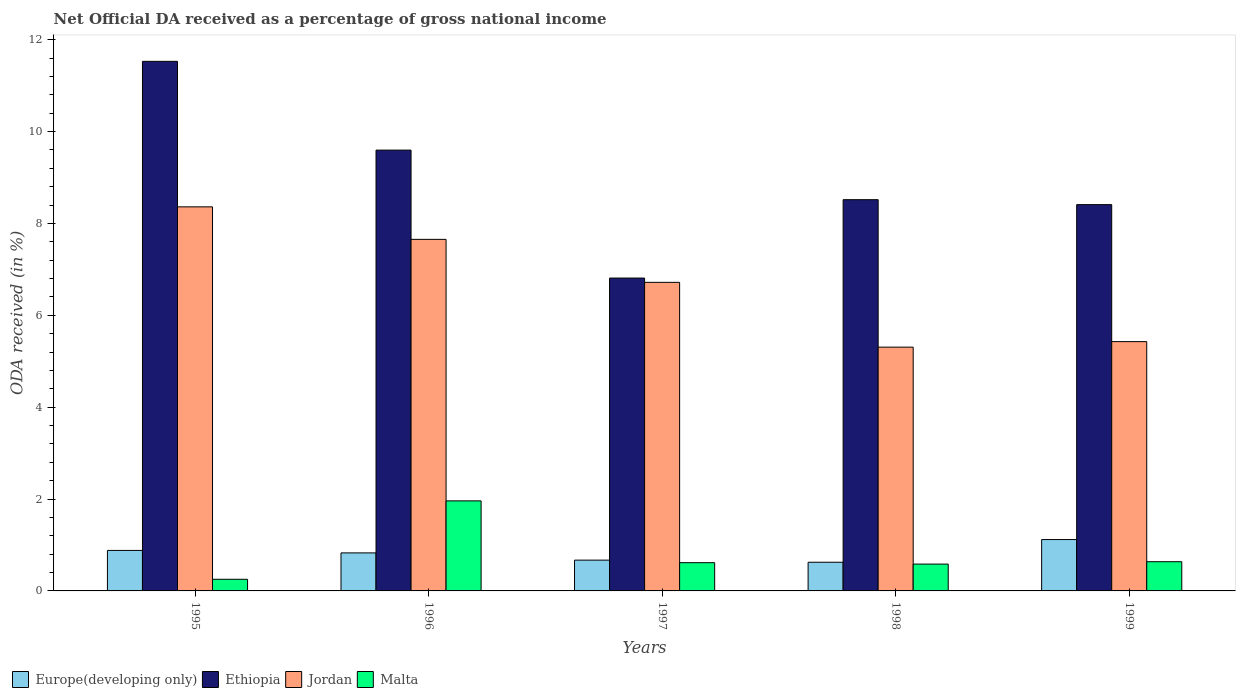How many groups of bars are there?
Give a very brief answer. 5. How many bars are there on the 2nd tick from the left?
Your answer should be very brief. 4. What is the label of the 4th group of bars from the left?
Offer a very short reply. 1998. In how many cases, is the number of bars for a given year not equal to the number of legend labels?
Your answer should be compact. 0. What is the net official DA received in Jordan in 1995?
Provide a short and direct response. 8.36. Across all years, what is the maximum net official DA received in Jordan?
Your response must be concise. 8.36. Across all years, what is the minimum net official DA received in Europe(developing only)?
Make the answer very short. 0.62. What is the total net official DA received in Jordan in the graph?
Your answer should be very brief. 33.46. What is the difference between the net official DA received in Jordan in 1997 and that in 1998?
Ensure brevity in your answer.  1.41. What is the difference between the net official DA received in Malta in 1997 and the net official DA received in Europe(developing only) in 1999?
Your answer should be compact. -0.5. What is the average net official DA received in Europe(developing only) per year?
Offer a very short reply. 0.82. In the year 1998, what is the difference between the net official DA received in Ethiopia and net official DA received in Europe(developing only)?
Keep it short and to the point. 7.89. In how many years, is the net official DA received in Jordan greater than 0.4 %?
Keep it short and to the point. 5. What is the ratio of the net official DA received in Malta in 1997 to that in 1998?
Ensure brevity in your answer.  1.05. Is the net official DA received in Europe(developing only) in 1996 less than that in 1999?
Keep it short and to the point. Yes. What is the difference between the highest and the second highest net official DA received in Malta?
Offer a very short reply. 1.32. What is the difference between the highest and the lowest net official DA received in Ethiopia?
Your response must be concise. 4.72. In how many years, is the net official DA received in Malta greater than the average net official DA received in Malta taken over all years?
Provide a succinct answer. 1. Is it the case that in every year, the sum of the net official DA received in Jordan and net official DA received in Ethiopia is greater than the sum of net official DA received in Malta and net official DA received in Europe(developing only)?
Keep it short and to the point. Yes. What does the 3rd bar from the left in 1997 represents?
Ensure brevity in your answer.  Jordan. What does the 2nd bar from the right in 1999 represents?
Your response must be concise. Jordan. Is it the case that in every year, the sum of the net official DA received in Ethiopia and net official DA received in Europe(developing only) is greater than the net official DA received in Malta?
Your answer should be very brief. Yes. How many bars are there?
Offer a terse response. 20. What is the difference between two consecutive major ticks on the Y-axis?
Give a very brief answer. 2. Does the graph contain any zero values?
Provide a short and direct response. No. How many legend labels are there?
Your answer should be very brief. 4. What is the title of the graph?
Give a very brief answer. Net Official DA received as a percentage of gross national income. What is the label or title of the X-axis?
Give a very brief answer. Years. What is the label or title of the Y-axis?
Make the answer very short. ODA received (in %). What is the ODA received (in %) in Europe(developing only) in 1995?
Ensure brevity in your answer.  0.88. What is the ODA received (in %) of Ethiopia in 1995?
Provide a succinct answer. 11.53. What is the ODA received (in %) of Jordan in 1995?
Provide a short and direct response. 8.36. What is the ODA received (in %) in Malta in 1995?
Provide a succinct answer. 0.25. What is the ODA received (in %) of Europe(developing only) in 1996?
Provide a succinct answer. 0.83. What is the ODA received (in %) in Ethiopia in 1996?
Your answer should be very brief. 9.6. What is the ODA received (in %) in Jordan in 1996?
Give a very brief answer. 7.65. What is the ODA received (in %) of Malta in 1996?
Give a very brief answer. 1.96. What is the ODA received (in %) of Europe(developing only) in 1997?
Make the answer very short. 0.67. What is the ODA received (in %) in Ethiopia in 1997?
Your response must be concise. 6.81. What is the ODA received (in %) in Jordan in 1997?
Give a very brief answer. 6.72. What is the ODA received (in %) of Malta in 1997?
Provide a short and direct response. 0.61. What is the ODA received (in %) in Europe(developing only) in 1998?
Keep it short and to the point. 0.62. What is the ODA received (in %) in Ethiopia in 1998?
Your response must be concise. 8.52. What is the ODA received (in %) in Jordan in 1998?
Give a very brief answer. 5.31. What is the ODA received (in %) in Malta in 1998?
Your response must be concise. 0.58. What is the ODA received (in %) in Europe(developing only) in 1999?
Your response must be concise. 1.12. What is the ODA received (in %) of Ethiopia in 1999?
Your answer should be very brief. 8.41. What is the ODA received (in %) of Jordan in 1999?
Make the answer very short. 5.43. What is the ODA received (in %) in Malta in 1999?
Your response must be concise. 0.64. Across all years, what is the maximum ODA received (in %) in Europe(developing only)?
Your answer should be very brief. 1.12. Across all years, what is the maximum ODA received (in %) in Ethiopia?
Make the answer very short. 11.53. Across all years, what is the maximum ODA received (in %) in Jordan?
Your answer should be very brief. 8.36. Across all years, what is the maximum ODA received (in %) of Malta?
Your response must be concise. 1.96. Across all years, what is the minimum ODA received (in %) of Europe(developing only)?
Your answer should be very brief. 0.62. Across all years, what is the minimum ODA received (in %) in Ethiopia?
Your response must be concise. 6.81. Across all years, what is the minimum ODA received (in %) in Jordan?
Keep it short and to the point. 5.31. Across all years, what is the minimum ODA received (in %) in Malta?
Your answer should be very brief. 0.25. What is the total ODA received (in %) in Europe(developing only) in the graph?
Your answer should be very brief. 4.12. What is the total ODA received (in %) of Ethiopia in the graph?
Provide a short and direct response. 44.86. What is the total ODA received (in %) in Jordan in the graph?
Keep it short and to the point. 33.46. What is the total ODA received (in %) in Malta in the graph?
Provide a short and direct response. 4.05. What is the difference between the ODA received (in %) of Europe(developing only) in 1995 and that in 1996?
Your response must be concise. 0.05. What is the difference between the ODA received (in %) of Ethiopia in 1995 and that in 1996?
Provide a short and direct response. 1.93. What is the difference between the ODA received (in %) in Jordan in 1995 and that in 1996?
Your answer should be very brief. 0.71. What is the difference between the ODA received (in %) of Malta in 1995 and that in 1996?
Ensure brevity in your answer.  -1.71. What is the difference between the ODA received (in %) in Europe(developing only) in 1995 and that in 1997?
Your response must be concise. 0.21. What is the difference between the ODA received (in %) of Ethiopia in 1995 and that in 1997?
Make the answer very short. 4.72. What is the difference between the ODA received (in %) of Jordan in 1995 and that in 1997?
Your answer should be very brief. 1.64. What is the difference between the ODA received (in %) in Malta in 1995 and that in 1997?
Give a very brief answer. -0.36. What is the difference between the ODA received (in %) of Europe(developing only) in 1995 and that in 1998?
Keep it short and to the point. 0.26. What is the difference between the ODA received (in %) in Ethiopia in 1995 and that in 1998?
Offer a terse response. 3.01. What is the difference between the ODA received (in %) of Jordan in 1995 and that in 1998?
Your answer should be compact. 3.05. What is the difference between the ODA received (in %) of Malta in 1995 and that in 1998?
Give a very brief answer. -0.33. What is the difference between the ODA received (in %) of Europe(developing only) in 1995 and that in 1999?
Your response must be concise. -0.24. What is the difference between the ODA received (in %) of Ethiopia in 1995 and that in 1999?
Offer a very short reply. 3.12. What is the difference between the ODA received (in %) in Jordan in 1995 and that in 1999?
Ensure brevity in your answer.  2.93. What is the difference between the ODA received (in %) in Malta in 1995 and that in 1999?
Provide a short and direct response. -0.38. What is the difference between the ODA received (in %) of Europe(developing only) in 1996 and that in 1997?
Ensure brevity in your answer.  0.16. What is the difference between the ODA received (in %) in Ethiopia in 1996 and that in 1997?
Provide a short and direct response. 2.78. What is the difference between the ODA received (in %) of Jordan in 1996 and that in 1997?
Give a very brief answer. 0.94. What is the difference between the ODA received (in %) of Malta in 1996 and that in 1997?
Offer a terse response. 1.35. What is the difference between the ODA received (in %) in Europe(developing only) in 1996 and that in 1998?
Make the answer very short. 0.2. What is the difference between the ODA received (in %) in Ethiopia in 1996 and that in 1998?
Keep it short and to the point. 1.08. What is the difference between the ODA received (in %) of Jordan in 1996 and that in 1998?
Give a very brief answer. 2.35. What is the difference between the ODA received (in %) of Malta in 1996 and that in 1998?
Provide a succinct answer. 1.38. What is the difference between the ODA received (in %) in Europe(developing only) in 1996 and that in 1999?
Your answer should be very brief. -0.29. What is the difference between the ODA received (in %) of Ethiopia in 1996 and that in 1999?
Keep it short and to the point. 1.19. What is the difference between the ODA received (in %) of Jordan in 1996 and that in 1999?
Offer a terse response. 2.23. What is the difference between the ODA received (in %) of Malta in 1996 and that in 1999?
Provide a short and direct response. 1.32. What is the difference between the ODA received (in %) in Europe(developing only) in 1997 and that in 1998?
Give a very brief answer. 0.05. What is the difference between the ODA received (in %) in Ethiopia in 1997 and that in 1998?
Give a very brief answer. -1.71. What is the difference between the ODA received (in %) in Jordan in 1997 and that in 1998?
Your answer should be very brief. 1.41. What is the difference between the ODA received (in %) of Malta in 1997 and that in 1998?
Provide a short and direct response. 0.03. What is the difference between the ODA received (in %) in Europe(developing only) in 1997 and that in 1999?
Offer a terse response. -0.45. What is the difference between the ODA received (in %) of Ethiopia in 1997 and that in 1999?
Offer a terse response. -1.6. What is the difference between the ODA received (in %) in Jordan in 1997 and that in 1999?
Your answer should be compact. 1.29. What is the difference between the ODA received (in %) in Malta in 1997 and that in 1999?
Give a very brief answer. -0.02. What is the difference between the ODA received (in %) in Europe(developing only) in 1998 and that in 1999?
Keep it short and to the point. -0.49. What is the difference between the ODA received (in %) in Ethiopia in 1998 and that in 1999?
Provide a short and direct response. 0.11. What is the difference between the ODA received (in %) of Jordan in 1998 and that in 1999?
Give a very brief answer. -0.12. What is the difference between the ODA received (in %) in Malta in 1998 and that in 1999?
Your response must be concise. -0.05. What is the difference between the ODA received (in %) of Europe(developing only) in 1995 and the ODA received (in %) of Ethiopia in 1996?
Provide a short and direct response. -8.71. What is the difference between the ODA received (in %) in Europe(developing only) in 1995 and the ODA received (in %) in Jordan in 1996?
Your answer should be compact. -6.77. What is the difference between the ODA received (in %) in Europe(developing only) in 1995 and the ODA received (in %) in Malta in 1996?
Your answer should be compact. -1.08. What is the difference between the ODA received (in %) in Ethiopia in 1995 and the ODA received (in %) in Jordan in 1996?
Ensure brevity in your answer.  3.87. What is the difference between the ODA received (in %) in Ethiopia in 1995 and the ODA received (in %) in Malta in 1996?
Ensure brevity in your answer.  9.57. What is the difference between the ODA received (in %) in Jordan in 1995 and the ODA received (in %) in Malta in 1996?
Your response must be concise. 6.4. What is the difference between the ODA received (in %) in Europe(developing only) in 1995 and the ODA received (in %) in Ethiopia in 1997?
Provide a succinct answer. -5.93. What is the difference between the ODA received (in %) of Europe(developing only) in 1995 and the ODA received (in %) of Jordan in 1997?
Your response must be concise. -5.84. What is the difference between the ODA received (in %) in Europe(developing only) in 1995 and the ODA received (in %) in Malta in 1997?
Provide a succinct answer. 0.27. What is the difference between the ODA received (in %) of Ethiopia in 1995 and the ODA received (in %) of Jordan in 1997?
Keep it short and to the point. 4.81. What is the difference between the ODA received (in %) of Ethiopia in 1995 and the ODA received (in %) of Malta in 1997?
Provide a short and direct response. 10.91. What is the difference between the ODA received (in %) of Jordan in 1995 and the ODA received (in %) of Malta in 1997?
Provide a short and direct response. 7.75. What is the difference between the ODA received (in %) of Europe(developing only) in 1995 and the ODA received (in %) of Ethiopia in 1998?
Offer a terse response. -7.63. What is the difference between the ODA received (in %) in Europe(developing only) in 1995 and the ODA received (in %) in Jordan in 1998?
Provide a short and direct response. -4.43. What is the difference between the ODA received (in %) in Europe(developing only) in 1995 and the ODA received (in %) in Malta in 1998?
Give a very brief answer. 0.3. What is the difference between the ODA received (in %) in Ethiopia in 1995 and the ODA received (in %) in Jordan in 1998?
Ensure brevity in your answer.  6.22. What is the difference between the ODA received (in %) in Ethiopia in 1995 and the ODA received (in %) in Malta in 1998?
Give a very brief answer. 10.94. What is the difference between the ODA received (in %) in Jordan in 1995 and the ODA received (in %) in Malta in 1998?
Your answer should be compact. 7.78. What is the difference between the ODA received (in %) of Europe(developing only) in 1995 and the ODA received (in %) of Ethiopia in 1999?
Ensure brevity in your answer.  -7.53. What is the difference between the ODA received (in %) in Europe(developing only) in 1995 and the ODA received (in %) in Jordan in 1999?
Your response must be concise. -4.55. What is the difference between the ODA received (in %) of Europe(developing only) in 1995 and the ODA received (in %) of Malta in 1999?
Make the answer very short. 0.25. What is the difference between the ODA received (in %) in Ethiopia in 1995 and the ODA received (in %) in Jordan in 1999?
Offer a very short reply. 6.1. What is the difference between the ODA received (in %) of Ethiopia in 1995 and the ODA received (in %) of Malta in 1999?
Your answer should be very brief. 10.89. What is the difference between the ODA received (in %) of Jordan in 1995 and the ODA received (in %) of Malta in 1999?
Provide a succinct answer. 7.72. What is the difference between the ODA received (in %) of Europe(developing only) in 1996 and the ODA received (in %) of Ethiopia in 1997?
Make the answer very short. -5.98. What is the difference between the ODA received (in %) of Europe(developing only) in 1996 and the ODA received (in %) of Jordan in 1997?
Keep it short and to the point. -5.89. What is the difference between the ODA received (in %) in Europe(developing only) in 1996 and the ODA received (in %) in Malta in 1997?
Your answer should be very brief. 0.21. What is the difference between the ODA received (in %) in Ethiopia in 1996 and the ODA received (in %) in Jordan in 1997?
Ensure brevity in your answer.  2.88. What is the difference between the ODA received (in %) of Ethiopia in 1996 and the ODA received (in %) of Malta in 1997?
Keep it short and to the point. 8.98. What is the difference between the ODA received (in %) in Jordan in 1996 and the ODA received (in %) in Malta in 1997?
Provide a succinct answer. 7.04. What is the difference between the ODA received (in %) of Europe(developing only) in 1996 and the ODA received (in %) of Ethiopia in 1998?
Your answer should be compact. -7.69. What is the difference between the ODA received (in %) in Europe(developing only) in 1996 and the ODA received (in %) in Jordan in 1998?
Offer a terse response. -4.48. What is the difference between the ODA received (in %) of Europe(developing only) in 1996 and the ODA received (in %) of Malta in 1998?
Your response must be concise. 0.24. What is the difference between the ODA received (in %) in Ethiopia in 1996 and the ODA received (in %) in Jordan in 1998?
Your answer should be very brief. 4.29. What is the difference between the ODA received (in %) of Ethiopia in 1996 and the ODA received (in %) of Malta in 1998?
Your answer should be very brief. 9.01. What is the difference between the ODA received (in %) of Jordan in 1996 and the ODA received (in %) of Malta in 1998?
Keep it short and to the point. 7.07. What is the difference between the ODA received (in %) of Europe(developing only) in 1996 and the ODA received (in %) of Ethiopia in 1999?
Your response must be concise. -7.58. What is the difference between the ODA received (in %) of Europe(developing only) in 1996 and the ODA received (in %) of Jordan in 1999?
Offer a very short reply. -4.6. What is the difference between the ODA received (in %) of Europe(developing only) in 1996 and the ODA received (in %) of Malta in 1999?
Provide a short and direct response. 0.19. What is the difference between the ODA received (in %) of Ethiopia in 1996 and the ODA received (in %) of Jordan in 1999?
Offer a very short reply. 4.17. What is the difference between the ODA received (in %) of Ethiopia in 1996 and the ODA received (in %) of Malta in 1999?
Give a very brief answer. 8.96. What is the difference between the ODA received (in %) in Jordan in 1996 and the ODA received (in %) in Malta in 1999?
Your answer should be very brief. 7.02. What is the difference between the ODA received (in %) in Europe(developing only) in 1997 and the ODA received (in %) in Ethiopia in 1998?
Give a very brief answer. -7.85. What is the difference between the ODA received (in %) in Europe(developing only) in 1997 and the ODA received (in %) in Jordan in 1998?
Make the answer very short. -4.64. What is the difference between the ODA received (in %) in Europe(developing only) in 1997 and the ODA received (in %) in Malta in 1998?
Provide a succinct answer. 0.09. What is the difference between the ODA received (in %) of Ethiopia in 1997 and the ODA received (in %) of Jordan in 1998?
Your answer should be compact. 1.5. What is the difference between the ODA received (in %) of Ethiopia in 1997 and the ODA received (in %) of Malta in 1998?
Your answer should be very brief. 6.23. What is the difference between the ODA received (in %) in Jordan in 1997 and the ODA received (in %) in Malta in 1998?
Offer a very short reply. 6.13. What is the difference between the ODA received (in %) in Europe(developing only) in 1997 and the ODA received (in %) in Ethiopia in 1999?
Keep it short and to the point. -7.74. What is the difference between the ODA received (in %) in Europe(developing only) in 1997 and the ODA received (in %) in Jordan in 1999?
Keep it short and to the point. -4.76. What is the difference between the ODA received (in %) of Europe(developing only) in 1997 and the ODA received (in %) of Malta in 1999?
Your answer should be very brief. 0.03. What is the difference between the ODA received (in %) of Ethiopia in 1997 and the ODA received (in %) of Jordan in 1999?
Your answer should be very brief. 1.38. What is the difference between the ODA received (in %) of Ethiopia in 1997 and the ODA received (in %) of Malta in 1999?
Offer a very short reply. 6.17. What is the difference between the ODA received (in %) of Jordan in 1997 and the ODA received (in %) of Malta in 1999?
Give a very brief answer. 6.08. What is the difference between the ODA received (in %) of Europe(developing only) in 1998 and the ODA received (in %) of Ethiopia in 1999?
Offer a very short reply. -7.78. What is the difference between the ODA received (in %) of Europe(developing only) in 1998 and the ODA received (in %) of Jordan in 1999?
Ensure brevity in your answer.  -4.8. What is the difference between the ODA received (in %) in Europe(developing only) in 1998 and the ODA received (in %) in Malta in 1999?
Provide a short and direct response. -0.01. What is the difference between the ODA received (in %) in Ethiopia in 1998 and the ODA received (in %) in Jordan in 1999?
Your answer should be compact. 3.09. What is the difference between the ODA received (in %) in Ethiopia in 1998 and the ODA received (in %) in Malta in 1999?
Offer a terse response. 7.88. What is the difference between the ODA received (in %) in Jordan in 1998 and the ODA received (in %) in Malta in 1999?
Your response must be concise. 4.67. What is the average ODA received (in %) of Europe(developing only) per year?
Your answer should be compact. 0.82. What is the average ODA received (in %) of Ethiopia per year?
Ensure brevity in your answer.  8.97. What is the average ODA received (in %) of Jordan per year?
Keep it short and to the point. 6.69. What is the average ODA received (in %) of Malta per year?
Keep it short and to the point. 0.81. In the year 1995, what is the difference between the ODA received (in %) of Europe(developing only) and ODA received (in %) of Ethiopia?
Your answer should be very brief. -10.65. In the year 1995, what is the difference between the ODA received (in %) of Europe(developing only) and ODA received (in %) of Jordan?
Provide a short and direct response. -7.48. In the year 1995, what is the difference between the ODA received (in %) in Europe(developing only) and ODA received (in %) in Malta?
Make the answer very short. 0.63. In the year 1995, what is the difference between the ODA received (in %) of Ethiopia and ODA received (in %) of Jordan?
Provide a short and direct response. 3.17. In the year 1995, what is the difference between the ODA received (in %) in Ethiopia and ODA received (in %) in Malta?
Your answer should be compact. 11.27. In the year 1995, what is the difference between the ODA received (in %) in Jordan and ODA received (in %) in Malta?
Offer a terse response. 8.11. In the year 1996, what is the difference between the ODA received (in %) of Europe(developing only) and ODA received (in %) of Ethiopia?
Your response must be concise. -8.77. In the year 1996, what is the difference between the ODA received (in %) of Europe(developing only) and ODA received (in %) of Jordan?
Your response must be concise. -6.83. In the year 1996, what is the difference between the ODA received (in %) of Europe(developing only) and ODA received (in %) of Malta?
Provide a succinct answer. -1.13. In the year 1996, what is the difference between the ODA received (in %) in Ethiopia and ODA received (in %) in Jordan?
Your answer should be very brief. 1.94. In the year 1996, what is the difference between the ODA received (in %) in Ethiopia and ODA received (in %) in Malta?
Provide a succinct answer. 7.64. In the year 1996, what is the difference between the ODA received (in %) in Jordan and ODA received (in %) in Malta?
Ensure brevity in your answer.  5.69. In the year 1997, what is the difference between the ODA received (in %) of Europe(developing only) and ODA received (in %) of Ethiopia?
Provide a succinct answer. -6.14. In the year 1997, what is the difference between the ODA received (in %) of Europe(developing only) and ODA received (in %) of Jordan?
Ensure brevity in your answer.  -6.05. In the year 1997, what is the difference between the ODA received (in %) in Europe(developing only) and ODA received (in %) in Malta?
Ensure brevity in your answer.  0.06. In the year 1997, what is the difference between the ODA received (in %) in Ethiopia and ODA received (in %) in Jordan?
Offer a very short reply. 0.09. In the year 1997, what is the difference between the ODA received (in %) in Ethiopia and ODA received (in %) in Malta?
Provide a succinct answer. 6.2. In the year 1997, what is the difference between the ODA received (in %) in Jordan and ODA received (in %) in Malta?
Your answer should be compact. 6.1. In the year 1998, what is the difference between the ODA received (in %) in Europe(developing only) and ODA received (in %) in Ethiopia?
Give a very brief answer. -7.89. In the year 1998, what is the difference between the ODA received (in %) in Europe(developing only) and ODA received (in %) in Jordan?
Provide a succinct answer. -4.68. In the year 1998, what is the difference between the ODA received (in %) in Europe(developing only) and ODA received (in %) in Malta?
Your answer should be compact. 0.04. In the year 1998, what is the difference between the ODA received (in %) of Ethiopia and ODA received (in %) of Jordan?
Offer a very short reply. 3.21. In the year 1998, what is the difference between the ODA received (in %) of Ethiopia and ODA received (in %) of Malta?
Your answer should be compact. 7.93. In the year 1998, what is the difference between the ODA received (in %) in Jordan and ODA received (in %) in Malta?
Your answer should be compact. 4.72. In the year 1999, what is the difference between the ODA received (in %) in Europe(developing only) and ODA received (in %) in Ethiopia?
Your answer should be very brief. -7.29. In the year 1999, what is the difference between the ODA received (in %) of Europe(developing only) and ODA received (in %) of Jordan?
Offer a very short reply. -4.31. In the year 1999, what is the difference between the ODA received (in %) of Europe(developing only) and ODA received (in %) of Malta?
Your answer should be compact. 0.48. In the year 1999, what is the difference between the ODA received (in %) of Ethiopia and ODA received (in %) of Jordan?
Your response must be concise. 2.98. In the year 1999, what is the difference between the ODA received (in %) of Ethiopia and ODA received (in %) of Malta?
Provide a short and direct response. 7.77. In the year 1999, what is the difference between the ODA received (in %) of Jordan and ODA received (in %) of Malta?
Provide a succinct answer. 4.79. What is the ratio of the ODA received (in %) in Europe(developing only) in 1995 to that in 1996?
Ensure brevity in your answer.  1.06. What is the ratio of the ODA received (in %) of Ethiopia in 1995 to that in 1996?
Keep it short and to the point. 1.2. What is the ratio of the ODA received (in %) in Jordan in 1995 to that in 1996?
Provide a succinct answer. 1.09. What is the ratio of the ODA received (in %) in Malta in 1995 to that in 1996?
Make the answer very short. 0.13. What is the ratio of the ODA received (in %) of Europe(developing only) in 1995 to that in 1997?
Provide a succinct answer. 1.31. What is the ratio of the ODA received (in %) in Ethiopia in 1995 to that in 1997?
Ensure brevity in your answer.  1.69. What is the ratio of the ODA received (in %) of Jordan in 1995 to that in 1997?
Provide a succinct answer. 1.24. What is the ratio of the ODA received (in %) of Malta in 1995 to that in 1997?
Give a very brief answer. 0.41. What is the ratio of the ODA received (in %) in Europe(developing only) in 1995 to that in 1998?
Offer a very short reply. 1.41. What is the ratio of the ODA received (in %) of Ethiopia in 1995 to that in 1998?
Offer a terse response. 1.35. What is the ratio of the ODA received (in %) of Jordan in 1995 to that in 1998?
Your response must be concise. 1.58. What is the ratio of the ODA received (in %) in Malta in 1995 to that in 1998?
Provide a succinct answer. 0.43. What is the ratio of the ODA received (in %) in Europe(developing only) in 1995 to that in 1999?
Offer a very short reply. 0.79. What is the ratio of the ODA received (in %) in Ethiopia in 1995 to that in 1999?
Make the answer very short. 1.37. What is the ratio of the ODA received (in %) of Jordan in 1995 to that in 1999?
Offer a very short reply. 1.54. What is the ratio of the ODA received (in %) of Malta in 1995 to that in 1999?
Make the answer very short. 0.4. What is the ratio of the ODA received (in %) of Europe(developing only) in 1996 to that in 1997?
Your answer should be very brief. 1.23. What is the ratio of the ODA received (in %) in Ethiopia in 1996 to that in 1997?
Provide a succinct answer. 1.41. What is the ratio of the ODA received (in %) in Jordan in 1996 to that in 1997?
Ensure brevity in your answer.  1.14. What is the ratio of the ODA received (in %) of Malta in 1996 to that in 1997?
Your answer should be compact. 3.19. What is the ratio of the ODA received (in %) in Europe(developing only) in 1996 to that in 1998?
Offer a terse response. 1.33. What is the ratio of the ODA received (in %) of Ethiopia in 1996 to that in 1998?
Keep it short and to the point. 1.13. What is the ratio of the ODA received (in %) of Jordan in 1996 to that in 1998?
Your response must be concise. 1.44. What is the ratio of the ODA received (in %) of Malta in 1996 to that in 1998?
Your answer should be compact. 3.36. What is the ratio of the ODA received (in %) in Europe(developing only) in 1996 to that in 1999?
Provide a succinct answer. 0.74. What is the ratio of the ODA received (in %) of Ethiopia in 1996 to that in 1999?
Ensure brevity in your answer.  1.14. What is the ratio of the ODA received (in %) of Jordan in 1996 to that in 1999?
Give a very brief answer. 1.41. What is the ratio of the ODA received (in %) in Malta in 1996 to that in 1999?
Offer a terse response. 3.08. What is the ratio of the ODA received (in %) in Europe(developing only) in 1997 to that in 1998?
Offer a terse response. 1.07. What is the ratio of the ODA received (in %) of Ethiopia in 1997 to that in 1998?
Offer a terse response. 0.8. What is the ratio of the ODA received (in %) of Jordan in 1997 to that in 1998?
Give a very brief answer. 1.27. What is the ratio of the ODA received (in %) in Malta in 1997 to that in 1998?
Your response must be concise. 1.05. What is the ratio of the ODA received (in %) of Europe(developing only) in 1997 to that in 1999?
Your response must be concise. 0.6. What is the ratio of the ODA received (in %) in Ethiopia in 1997 to that in 1999?
Offer a very short reply. 0.81. What is the ratio of the ODA received (in %) of Jordan in 1997 to that in 1999?
Your response must be concise. 1.24. What is the ratio of the ODA received (in %) in Malta in 1997 to that in 1999?
Your answer should be compact. 0.97. What is the ratio of the ODA received (in %) of Europe(developing only) in 1998 to that in 1999?
Make the answer very short. 0.56. What is the ratio of the ODA received (in %) of Ethiopia in 1998 to that in 1999?
Keep it short and to the point. 1.01. What is the ratio of the ODA received (in %) in Jordan in 1998 to that in 1999?
Provide a succinct answer. 0.98. What is the ratio of the ODA received (in %) in Malta in 1998 to that in 1999?
Offer a terse response. 0.92. What is the difference between the highest and the second highest ODA received (in %) in Europe(developing only)?
Give a very brief answer. 0.24. What is the difference between the highest and the second highest ODA received (in %) in Ethiopia?
Offer a very short reply. 1.93. What is the difference between the highest and the second highest ODA received (in %) of Jordan?
Your answer should be very brief. 0.71. What is the difference between the highest and the second highest ODA received (in %) in Malta?
Ensure brevity in your answer.  1.32. What is the difference between the highest and the lowest ODA received (in %) of Europe(developing only)?
Your answer should be very brief. 0.49. What is the difference between the highest and the lowest ODA received (in %) of Ethiopia?
Your answer should be compact. 4.72. What is the difference between the highest and the lowest ODA received (in %) of Jordan?
Your response must be concise. 3.05. What is the difference between the highest and the lowest ODA received (in %) of Malta?
Make the answer very short. 1.71. 